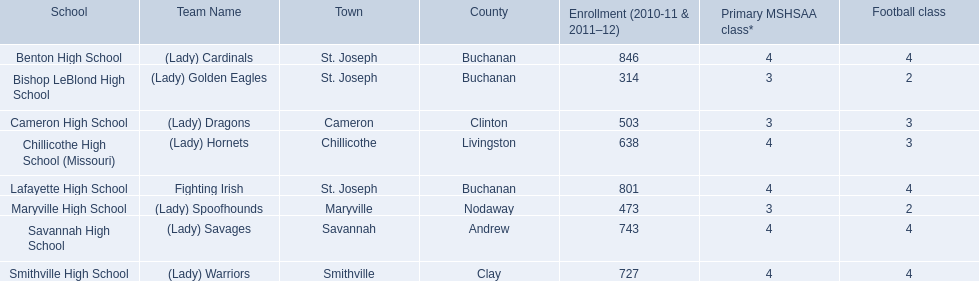What are the names of the schools? Benton High School, Bishop LeBlond High School, Cameron High School, Chillicothe High School (Missouri), Lafayette High School, Maryville High School, Savannah High School, Smithville High School. Out of these, which schools have a total enrollment of under 500 students? Bishop LeBlond High School, Maryville High School. And from those schools, which one has the least number of enrolled students? Bishop LeBlond High School. 